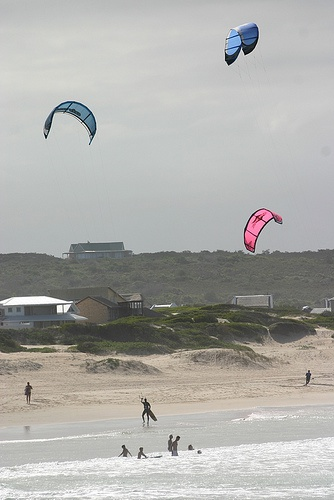Describe the objects in this image and their specific colors. I can see kite in darkgray, black, lightblue, lightgray, and gray tones, kite in darkgray, gray, black, and blue tones, kite in darkgray, lightpink, and black tones, people in darkgray, black, gray, and lightgray tones, and people in darkgray, gray, and black tones in this image. 